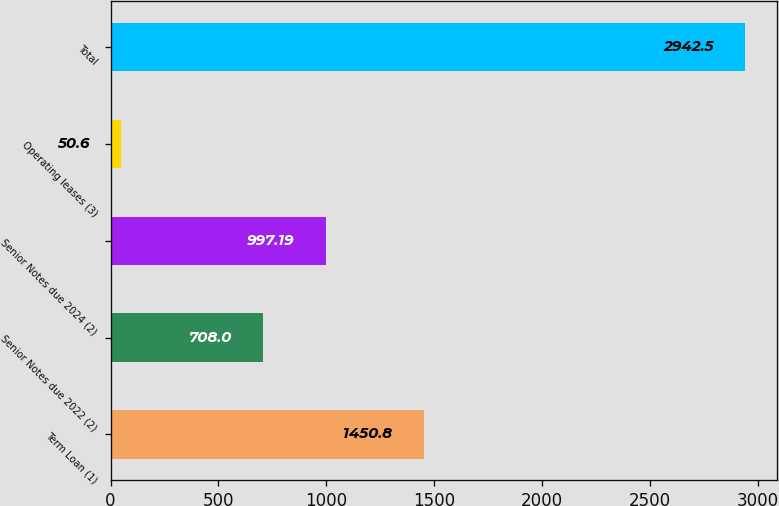Convert chart. <chart><loc_0><loc_0><loc_500><loc_500><bar_chart><fcel>Term Loan (1)<fcel>Senior Notes due 2022 (2)<fcel>Senior Notes due 2024 (2)<fcel>Operating leases (3)<fcel>Total<nl><fcel>1450.8<fcel>708<fcel>997.19<fcel>50.6<fcel>2942.5<nl></chart> 